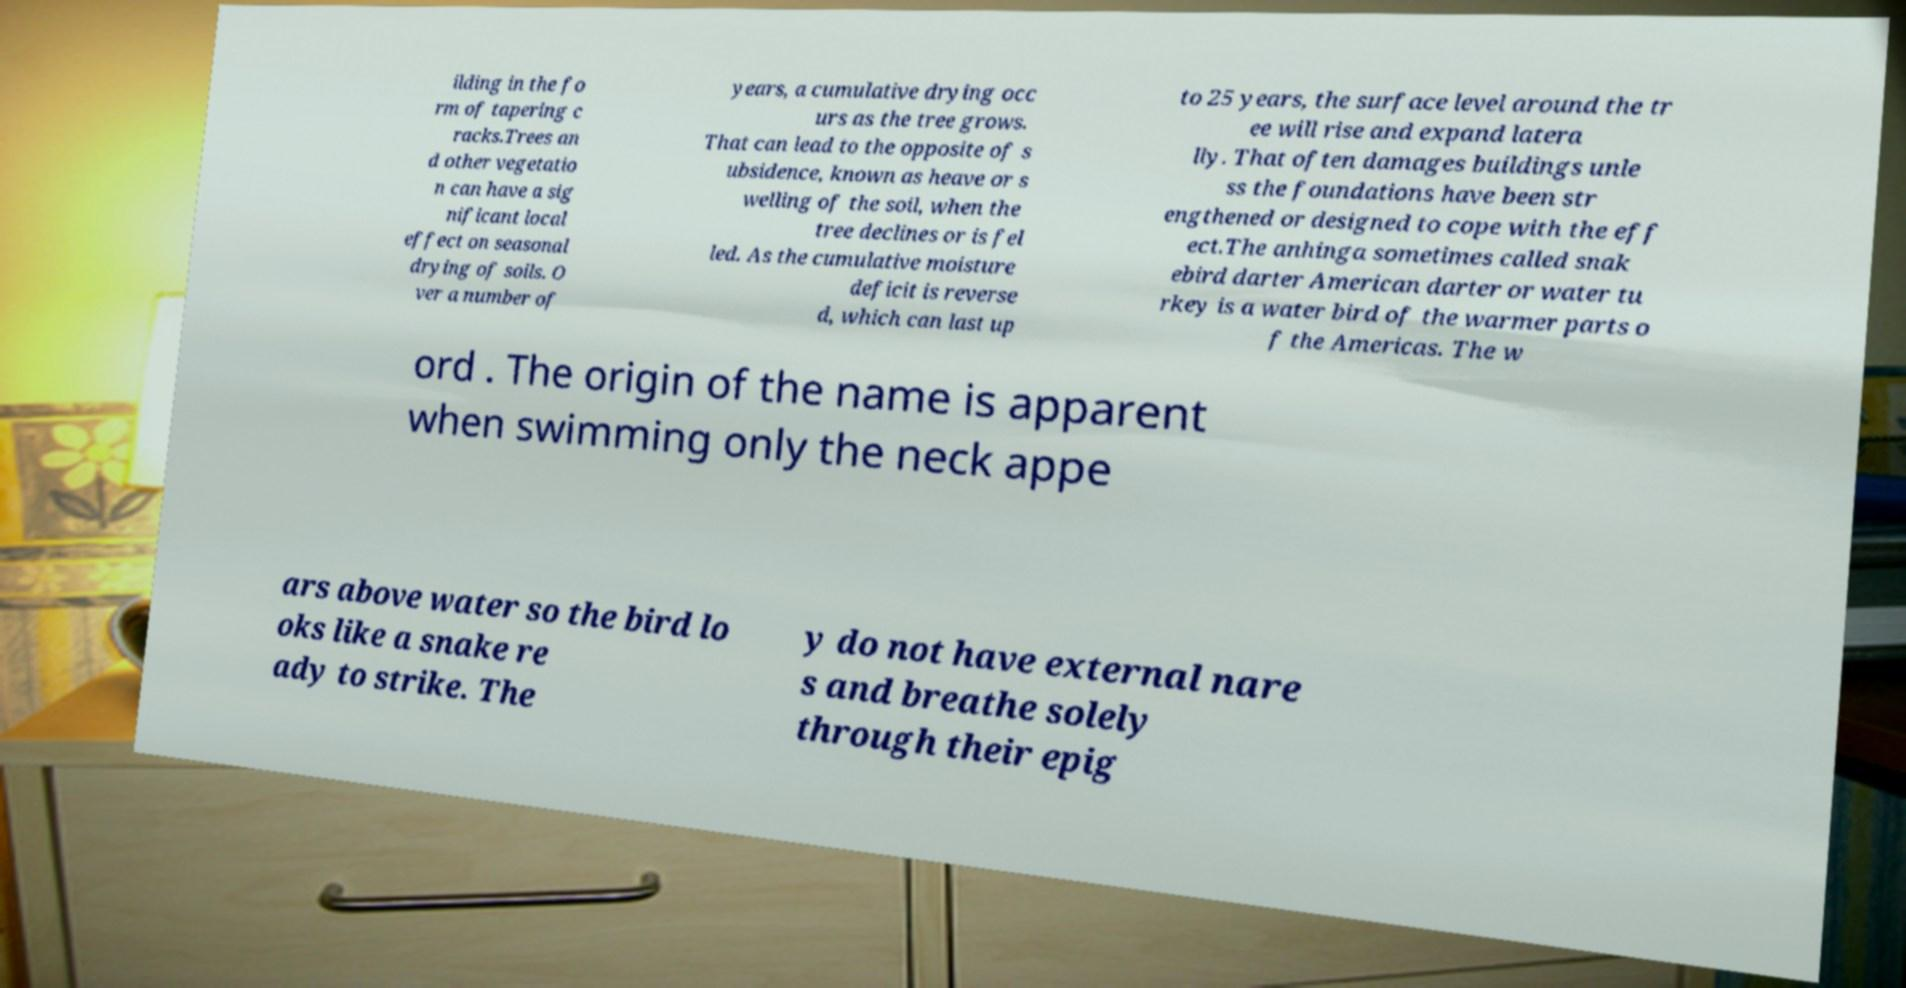Please read and relay the text visible in this image. What does it say? ilding in the fo rm of tapering c racks.Trees an d other vegetatio n can have a sig nificant local effect on seasonal drying of soils. O ver a number of years, a cumulative drying occ urs as the tree grows. That can lead to the opposite of s ubsidence, known as heave or s welling of the soil, when the tree declines or is fel led. As the cumulative moisture deficit is reverse d, which can last up to 25 years, the surface level around the tr ee will rise and expand latera lly. That often damages buildings unle ss the foundations have been str engthened or designed to cope with the eff ect.The anhinga sometimes called snak ebird darter American darter or water tu rkey is a water bird of the warmer parts o f the Americas. The w ord . The origin of the name is apparent when swimming only the neck appe ars above water so the bird lo oks like a snake re ady to strike. The y do not have external nare s and breathe solely through their epig 